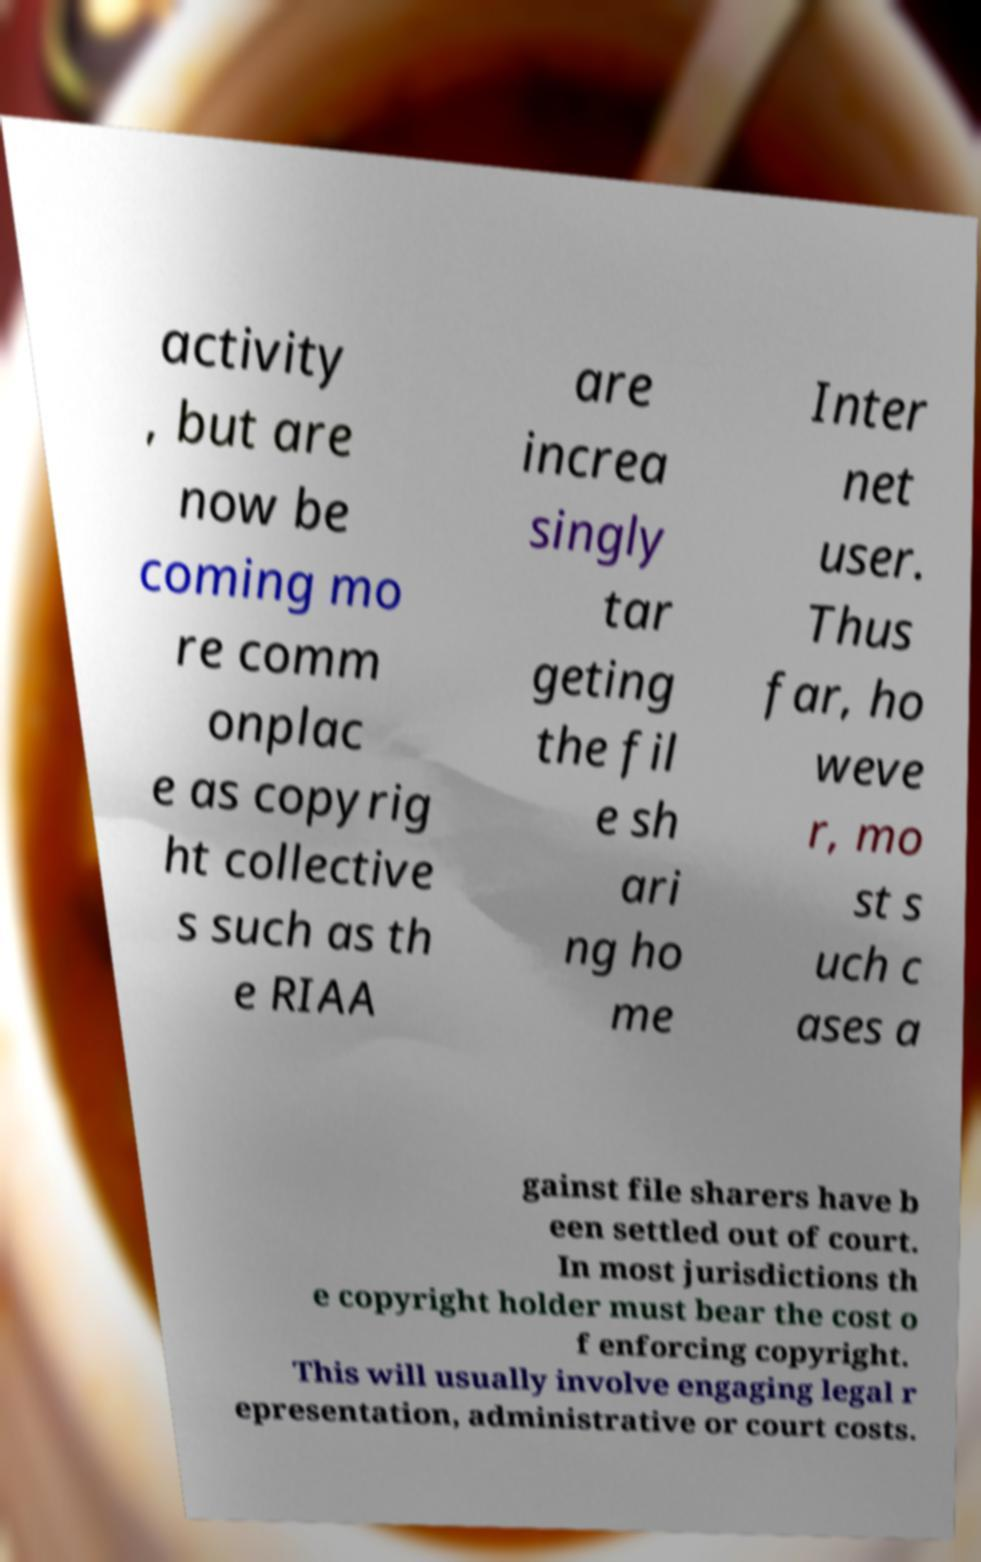What messages or text are displayed in this image? I need them in a readable, typed format. activity , but are now be coming mo re comm onplac e as copyrig ht collective s such as th e RIAA are increa singly tar geting the fil e sh ari ng ho me Inter net user. Thus far, ho weve r, mo st s uch c ases a gainst file sharers have b een settled out of court. In most jurisdictions th e copyright holder must bear the cost o f enforcing copyright. This will usually involve engaging legal r epresentation, administrative or court costs. 